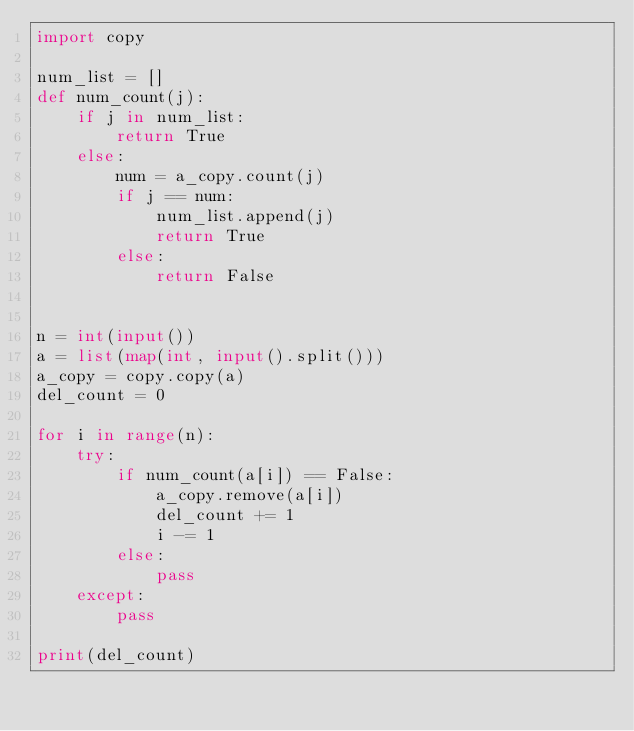<code> <loc_0><loc_0><loc_500><loc_500><_Python_>import copy

num_list = []
def num_count(j):
    if j in num_list:
        return True
    else:
        num = a_copy.count(j)
        if j == num:
            num_list.append(j)
            return True
        else:
            return False
        

n = int(input())
a = list(map(int, input().split()))
a_copy = copy.copy(a)
del_count = 0

for i in range(n):
    try:
        if num_count(a[i]) == False:
            a_copy.remove(a[i])
            del_count += 1
            i -= 1
        else:
            pass
    except:
        pass

print(del_count)</code> 